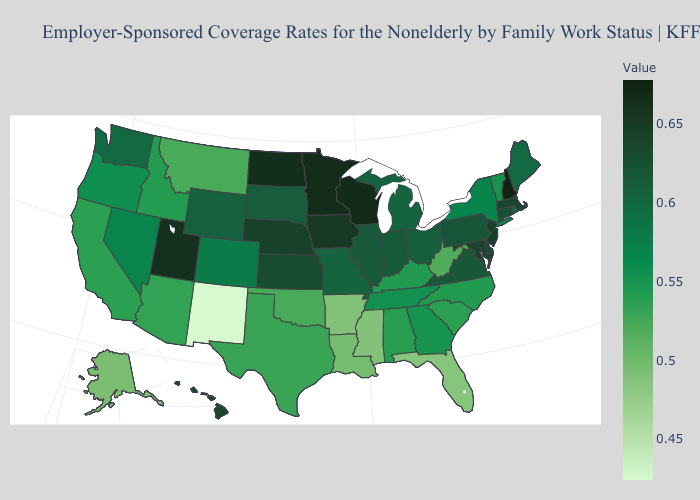Does Utah have the highest value in the West?
Quick response, please. Yes. Does Florida have the highest value in the South?
Short answer required. No. Does Illinois have the highest value in the USA?
Give a very brief answer. No. Among the states that border Virginia , does Kentucky have the highest value?
Be succinct. No. Among the states that border South Carolina , does Georgia have the lowest value?
Keep it brief. No. Which states have the lowest value in the West?
Short answer required. New Mexico. 